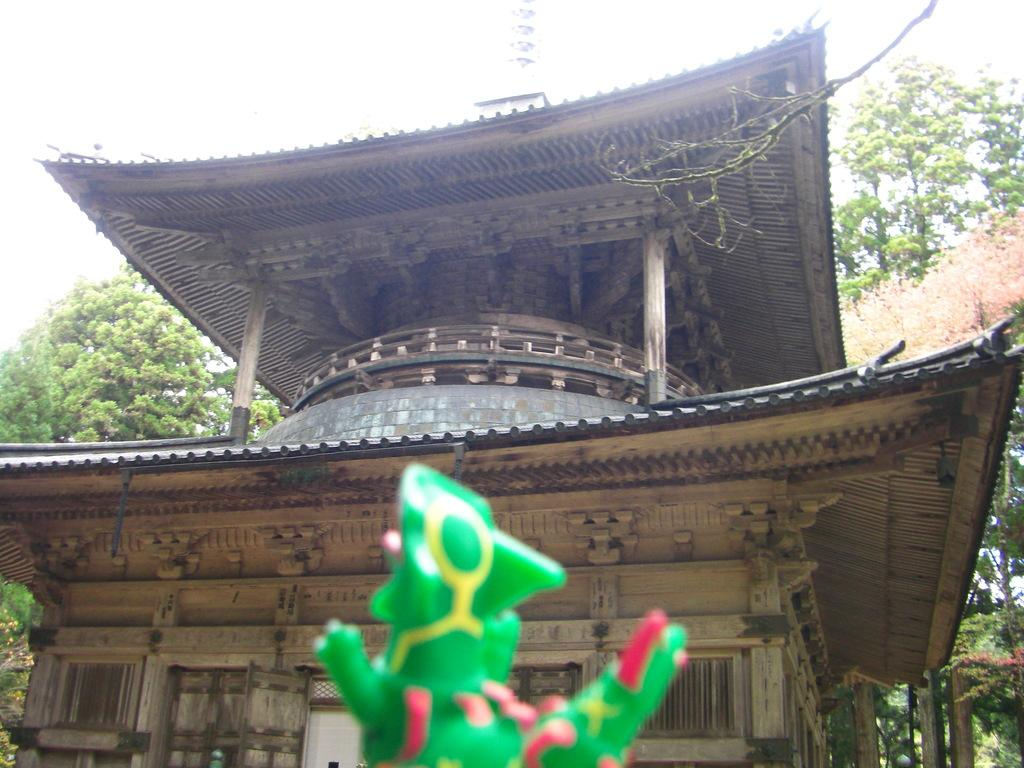What type of structure is present in the image? There is a temple in the image. What can be seen behind the temple? Trees are visible behind the temple in the image. What other object is visible in the image besides the temple and trees? There is an object that appears to be a toy in the image. What is visible above the temple and the toy? The sky is visible above the temple and the toy in the image. What type of crate is being used to store the eggnog in the image? There is no crate or eggnog present in the image. How does the hair of the person in the image look like? There is no person present in the image, so we cannot determine the appearance of their hair. 